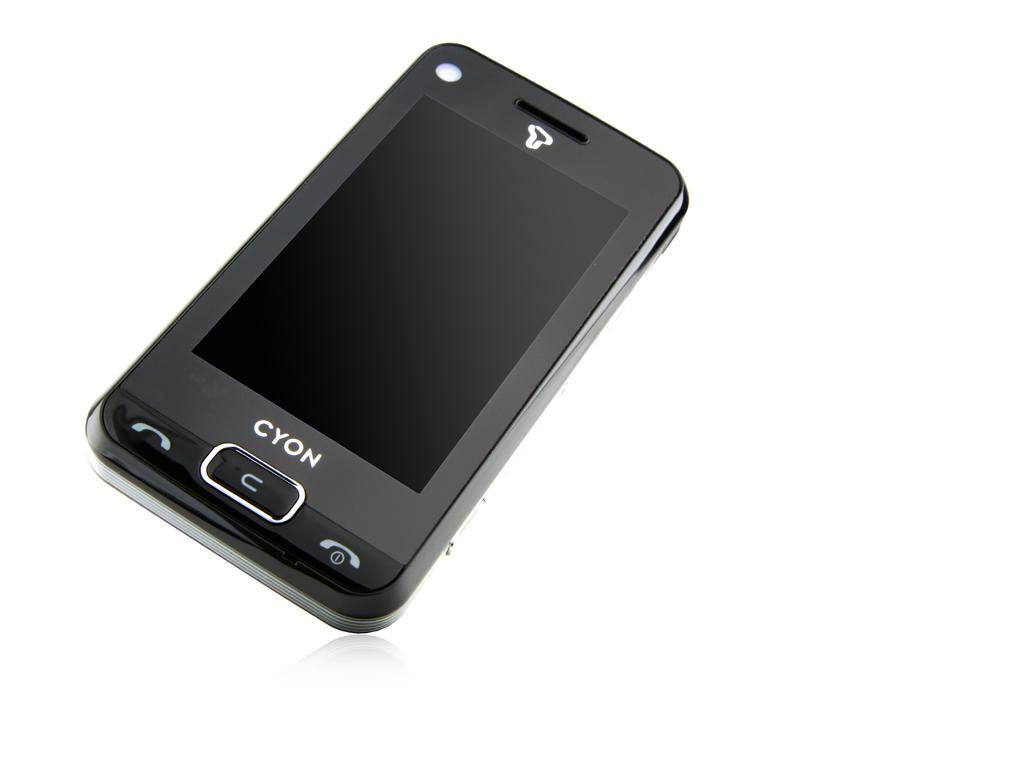Provide a one-sentence caption for the provided image. a black cell phone named Cyon has very few buttons. 